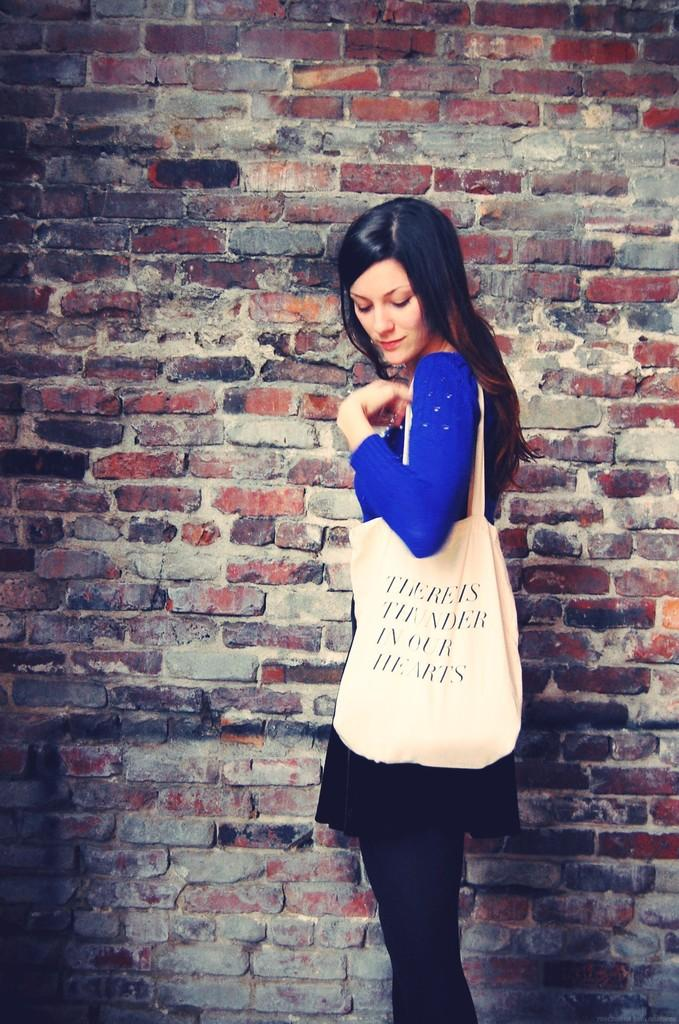Who is present in the image? There is a woman in the image. What is the woman wearing? The woman is wearing a bag. Where is the woman located in the image? The woman is standing beside a wall. What type of salt can be seen on the ground in the image? There is no salt visible on the ground in the image. What type of alley is the woman standing in the image? The image does not show an alley; it only shows the woman standing beside a wall. 